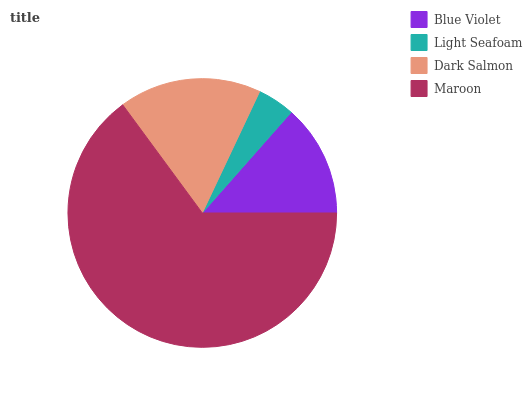Is Light Seafoam the minimum?
Answer yes or no. Yes. Is Maroon the maximum?
Answer yes or no. Yes. Is Dark Salmon the minimum?
Answer yes or no. No. Is Dark Salmon the maximum?
Answer yes or no. No. Is Dark Salmon greater than Light Seafoam?
Answer yes or no. Yes. Is Light Seafoam less than Dark Salmon?
Answer yes or no. Yes. Is Light Seafoam greater than Dark Salmon?
Answer yes or no. No. Is Dark Salmon less than Light Seafoam?
Answer yes or no. No. Is Dark Salmon the high median?
Answer yes or no. Yes. Is Blue Violet the low median?
Answer yes or no. Yes. Is Light Seafoam the high median?
Answer yes or no. No. Is Maroon the low median?
Answer yes or no. No. 